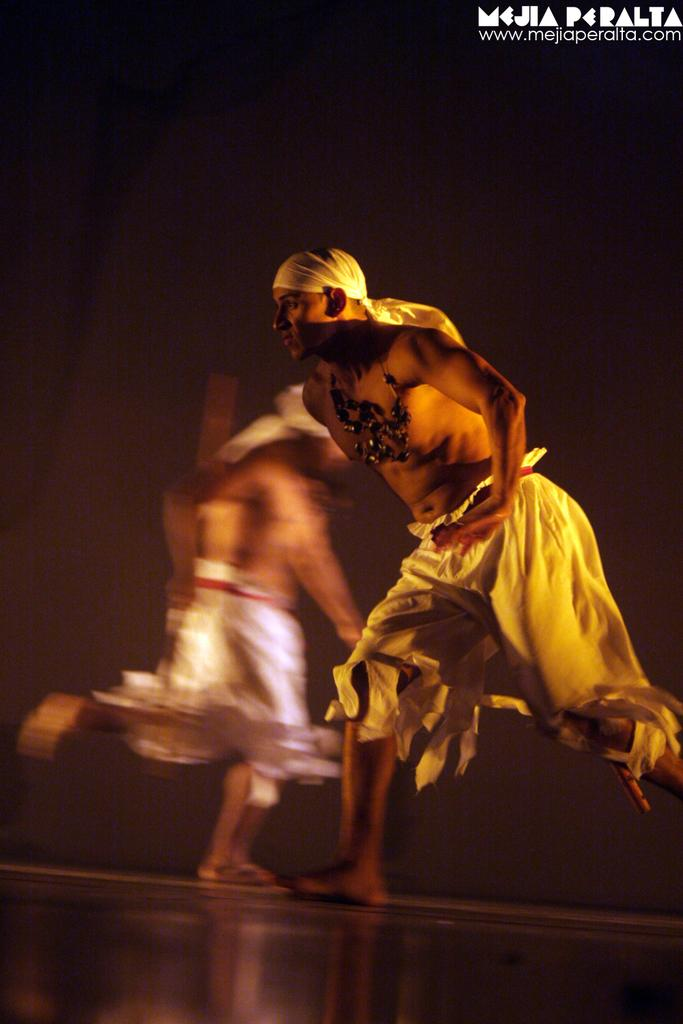What is the main action being performed by the man in the image? The man is running in the image. Can you describe any additional details about the man's appearance? The man has a cloth tied to his head. What can be seen happening in the background of the image? There are other people running in the background of the image. Where is the sister of the man in the image? There is no mention of a sister in the image, so it cannot be determined where she might be. 